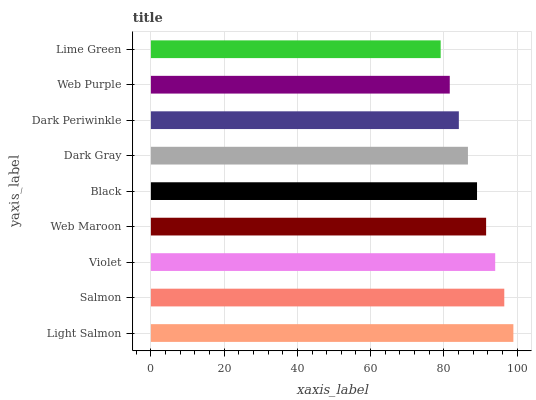Is Lime Green the minimum?
Answer yes or no. Yes. Is Light Salmon the maximum?
Answer yes or no. Yes. Is Salmon the minimum?
Answer yes or no. No. Is Salmon the maximum?
Answer yes or no. No. Is Light Salmon greater than Salmon?
Answer yes or no. Yes. Is Salmon less than Light Salmon?
Answer yes or no. Yes. Is Salmon greater than Light Salmon?
Answer yes or no. No. Is Light Salmon less than Salmon?
Answer yes or no. No. Is Black the high median?
Answer yes or no. Yes. Is Black the low median?
Answer yes or no. Yes. Is Lime Green the high median?
Answer yes or no. No. Is Web Maroon the low median?
Answer yes or no. No. 